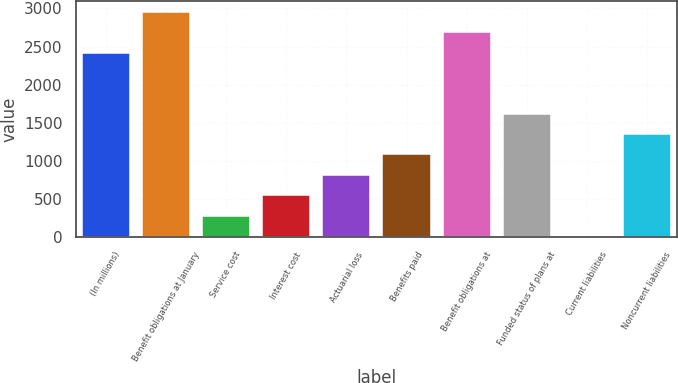Convert chart. <chart><loc_0><loc_0><loc_500><loc_500><bar_chart><fcel>(In millions)<fcel>Benefit obligations at January<fcel>Service cost<fcel>Interest cost<fcel>Actuarial loss<fcel>Benefits paid<fcel>Benefit obligations at<fcel>Funded status of plans at<fcel>Current liabilities<fcel>Noncurrent liabilities<nl><fcel>2418.3<fcel>2951.7<fcel>284.7<fcel>551.4<fcel>818.1<fcel>1084.8<fcel>2685<fcel>1618.2<fcel>18<fcel>1351.5<nl></chart> 